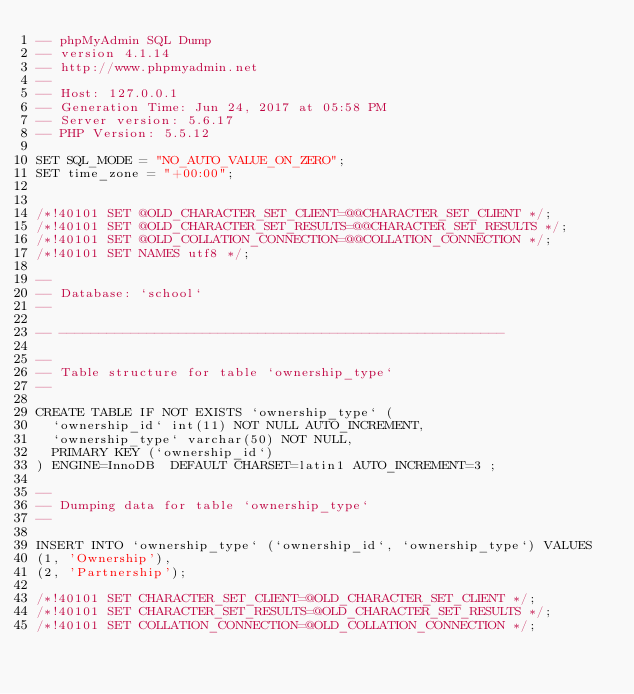<code> <loc_0><loc_0><loc_500><loc_500><_SQL_>-- phpMyAdmin SQL Dump
-- version 4.1.14
-- http://www.phpmyadmin.net
--
-- Host: 127.0.0.1
-- Generation Time: Jun 24, 2017 at 05:58 PM
-- Server version: 5.6.17
-- PHP Version: 5.5.12

SET SQL_MODE = "NO_AUTO_VALUE_ON_ZERO";
SET time_zone = "+00:00";


/*!40101 SET @OLD_CHARACTER_SET_CLIENT=@@CHARACTER_SET_CLIENT */;
/*!40101 SET @OLD_CHARACTER_SET_RESULTS=@@CHARACTER_SET_RESULTS */;
/*!40101 SET @OLD_COLLATION_CONNECTION=@@COLLATION_CONNECTION */;
/*!40101 SET NAMES utf8 */;

--
-- Database: `school`
--

-- --------------------------------------------------------

--
-- Table structure for table `ownership_type`
--

CREATE TABLE IF NOT EXISTS `ownership_type` (
  `ownership_id` int(11) NOT NULL AUTO_INCREMENT,
  `ownership_type` varchar(50) NOT NULL,
  PRIMARY KEY (`ownership_id`)
) ENGINE=InnoDB  DEFAULT CHARSET=latin1 AUTO_INCREMENT=3 ;

--
-- Dumping data for table `ownership_type`
--

INSERT INTO `ownership_type` (`ownership_id`, `ownership_type`) VALUES
(1, 'Ownership'),
(2, 'Partnership');

/*!40101 SET CHARACTER_SET_CLIENT=@OLD_CHARACTER_SET_CLIENT */;
/*!40101 SET CHARACTER_SET_RESULTS=@OLD_CHARACTER_SET_RESULTS */;
/*!40101 SET COLLATION_CONNECTION=@OLD_COLLATION_CONNECTION */;
</code> 